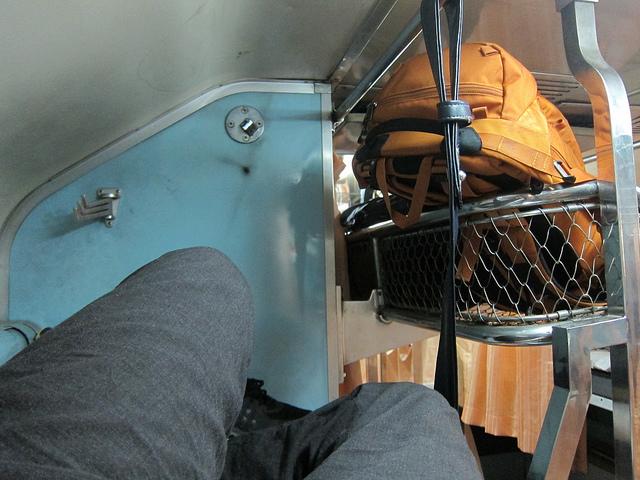Where are the knees?
Be succinct. Middle of picture. What is in the bin?
Answer briefly. Backpack. What color are the pants?
Give a very brief answer. Gray. 